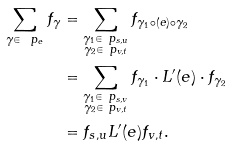Convert formula to latex. <formula><loc_0><loc_0><loc_500><loc_500>\sum _ { \gamma \in \ p _ { e } } f _ { \gamma } & = \sum _ { \substack { \gamma _ { 1 } \in \ p _ { s , u } \\ \gamma _ { 2 } \in \ p _ { v , t } } } f _ { \gamma _ { 1 } \circ ( e ) \circ \gamma _ { 2 } } \\ & = \sum _ { \substack { \gamma _ { 1 } \in \ p _ { s , v } \\ \gamma _ { 2 } \in \ p _ { v , t } } } f _ { \gamma _ { 1 } } \cdot L ^ { \prime } ( e ) \cdot f _ { \gamma _ { 2 } } \\ & = f _ { s , u } L ^ { \prime } ( e ) f _ { v , t } . \\</formula> 